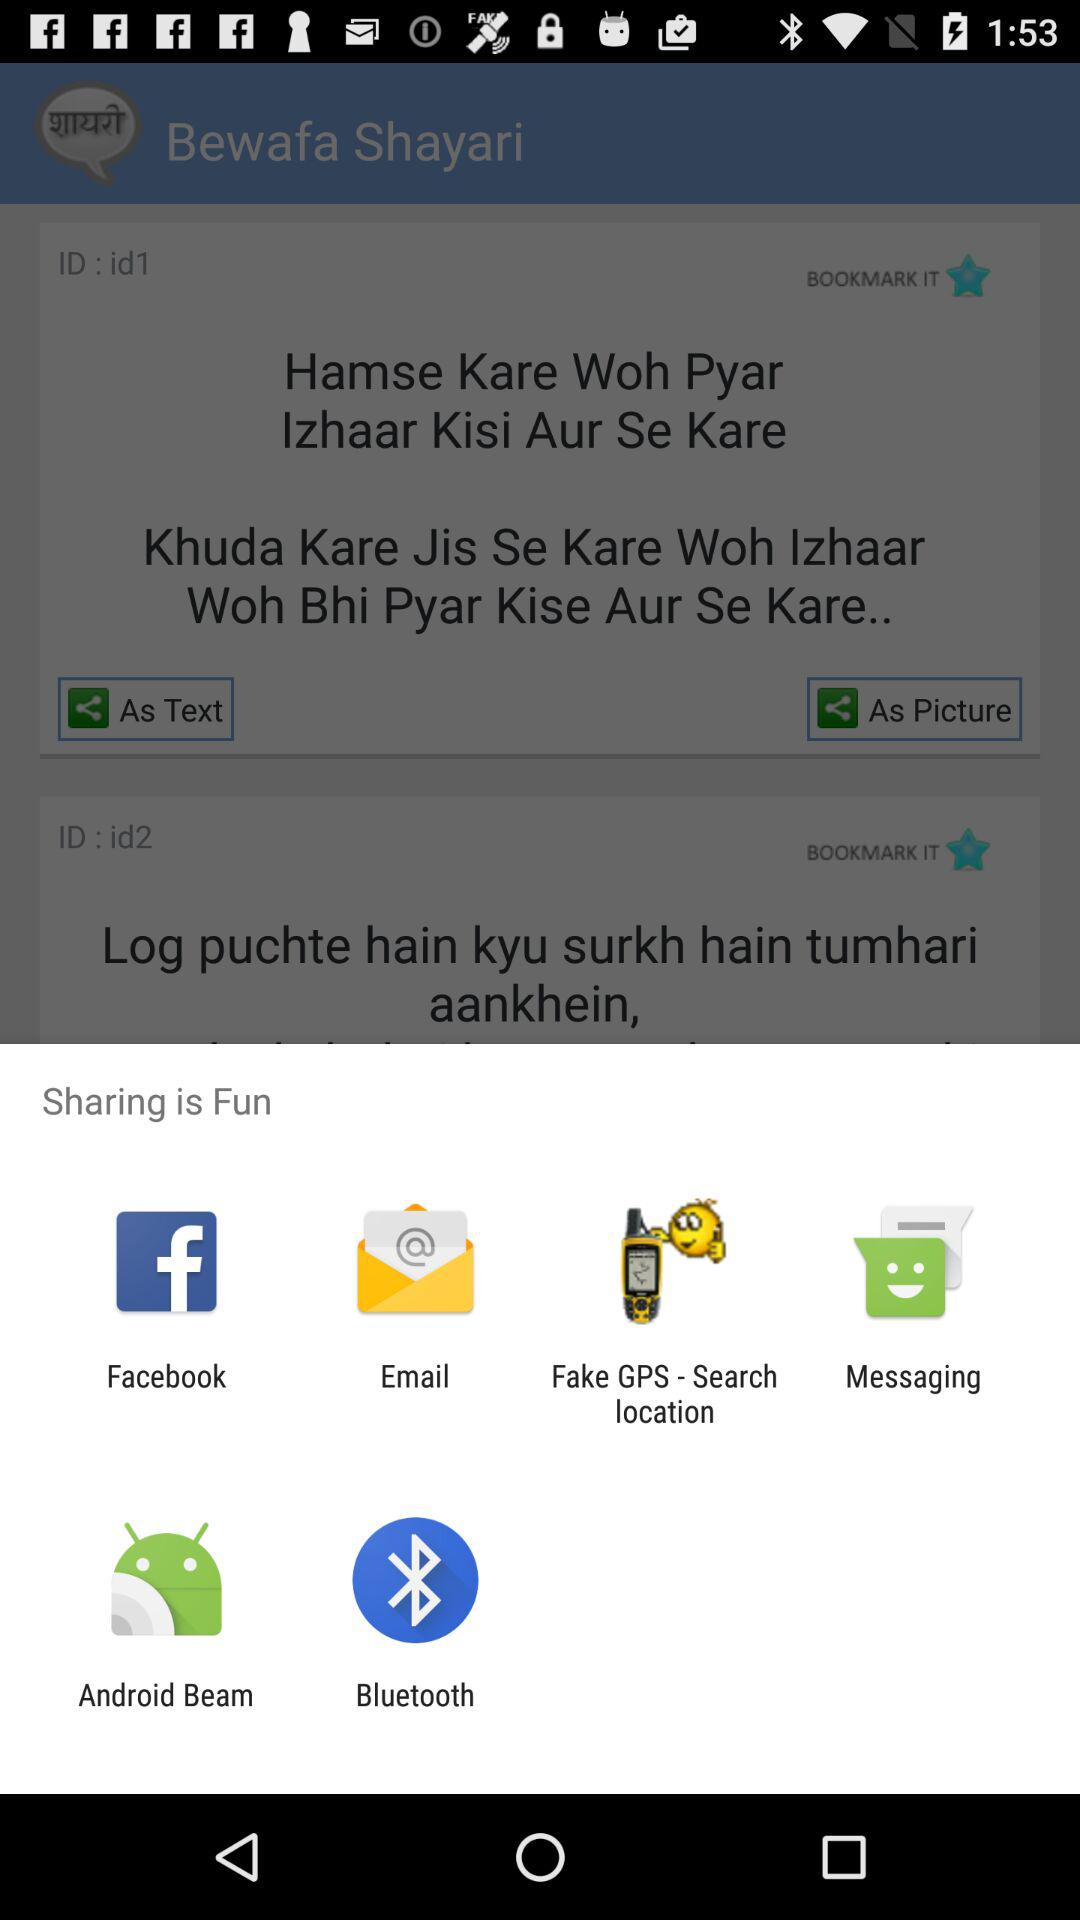What are the different mediums to share? The different mediums are "Facebook", "Email", "Fake GPS - Search location", "Messaging", "Android Beam" and "Bluetooth". 